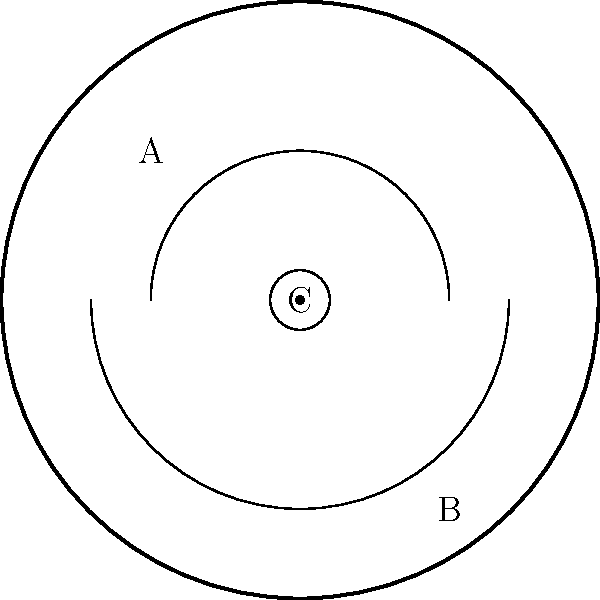Consider the topological space represented by a vinyl record album cover. If we identify the outer edge (A) with the inner circle (B) and collapse the center point (C) to a single point, what is the resulting topological surface? How does this relate to the classification of surfaces in topology? To determine the resulting topological surface, let's follow these steps:

1. First, we need to understand the initial structure:
   - The outer edge (A) represents the boundary of the album cover.
   - The inner circle (B) represents the label area of the vinyl record.
   - The center point (C) represents the spindle hole.

2. We're asked to perform two operations:
   a) Identify (glue together) the outer edge (A) with the inner circle (B).
   b) Collapse the center point (C) to a single point.

3. When we identify A with B, we're essentially creating a cylinder-like structure. The top and bottom of this cylinder are connected by the identification.

4. Collapsing the center point C to a single point has the effect of pinching the center of our cylinder-like structure.

5. The resulting surface is homeomorphic to a sphere with two points identified (often called a pinched sphere).

6. In the classification of surfaces, this topological space is equivalent to a sphere. The pinched point doesn't change its fundamental topological characteristics.

7. The sphere is a fundamental surface in topology, characterized by having genus 0 and being orientable.

8. This transformation demonstrates how different-looking spaces (like an album cover) can be topologically equivalent to simpler, well-known surfaces (like a sphere).

9. In the context of Big Star and Alex Chilton, we could imagine this process as taking their iconic album "#1 Record" and transforming its physical form while preserving its essential "Big Star-ness" - much like how their music transformed rock while maintaining its essence.
Answer: Sphere 